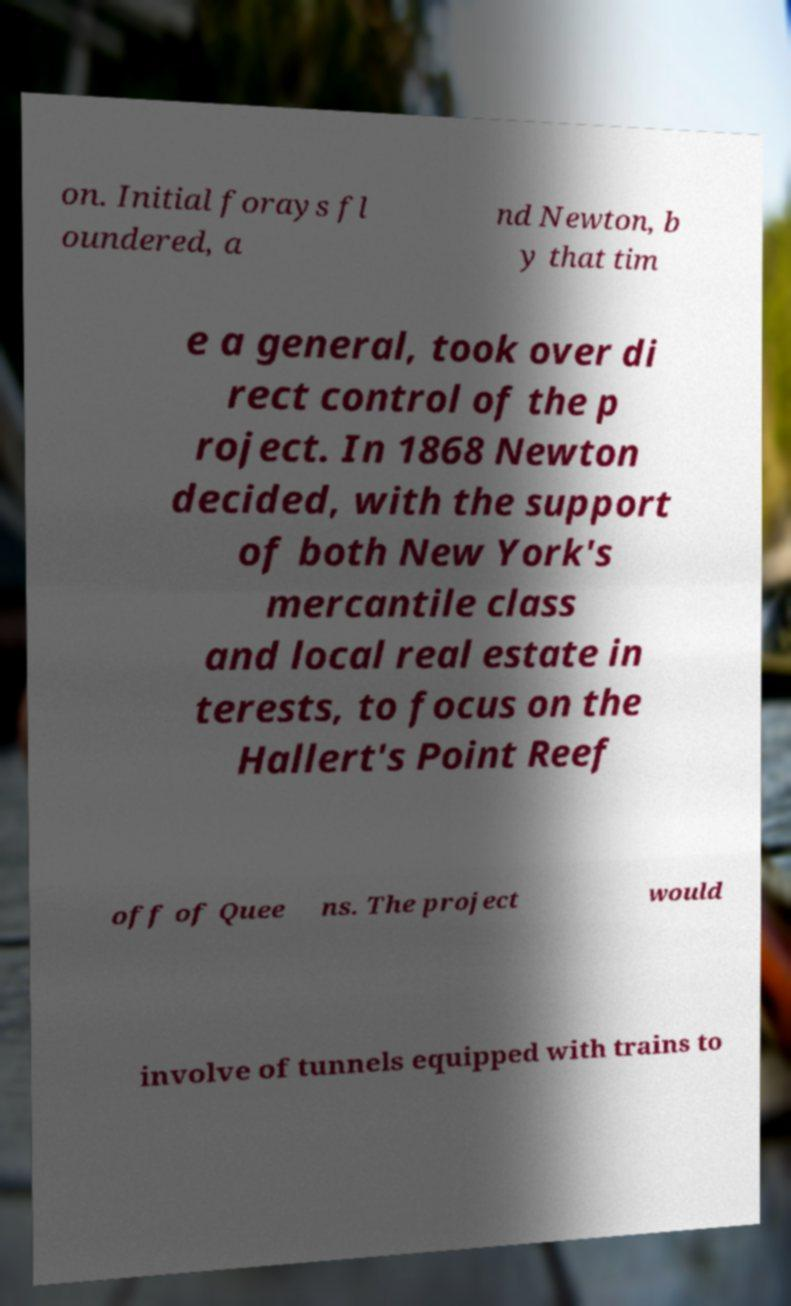Could you extract and type out the text from this image? on. Initial forays fl oundered, a nd Newton, b y that tim e a general, took over di rect control of the p roject. In 1868 Newton decided, with the support of both New York's mercantile class and local real estate in terests, to focus on the Hallert's Point Reef off of Quee ns. The project would involve of tunnels equipped with trains to 